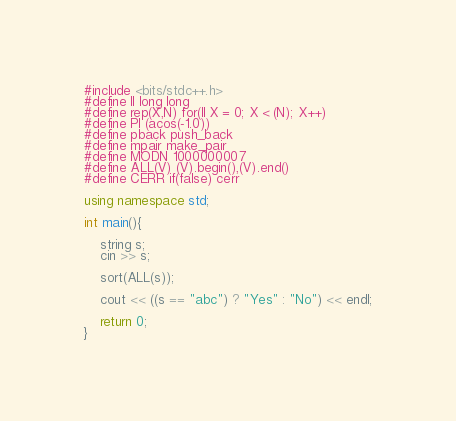Convert code to text. <code><loc_0><loc_0><loc_500><loc_500><_C++_>#include <bits/stdc++.h>
#define ll long long
#define rep(X,N) for(ll X = 0; X < (N); X++)
#define PI (acos(-1.0))
#define pback push_back
#define mpair make_pair
#define MODN 1000000007
#define ALL(V) (V).begin(),(V).end() 
#define CERR if(false) cerr

using namespace std;

int main(){

    string s;
    cin >> s;

    sort(ALL(s));

    cout << ((s == "abc") ? "Yes" : "No") << endl;

    return 0;
}</code> 